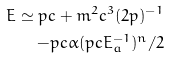<formula> <loc_0><loc_0><loc_500><loc_500>E \simeq p c + m ^ { 2 } c ^ { 3 } ( 2 p ) ^ { - 1 } \\ - p c \alpha ( p c E _ { a } ^ { - 1 } ) ^ { n } / 2</formula> 